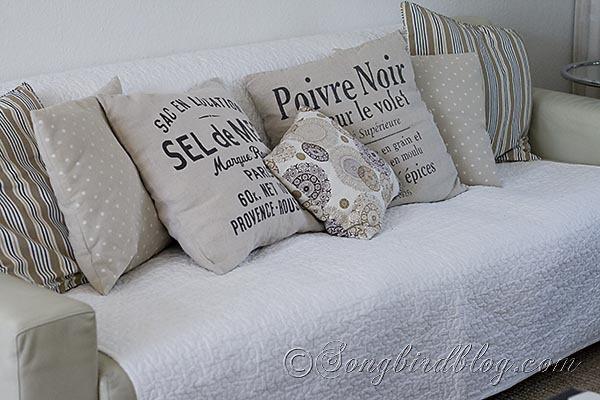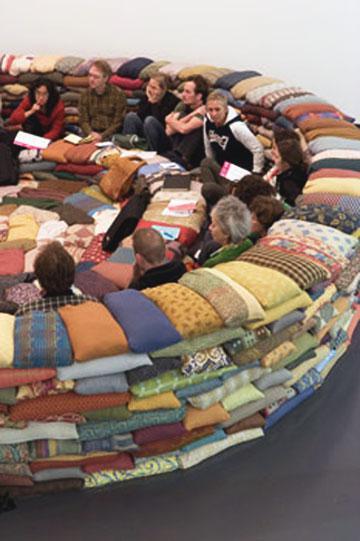The first image is the image on the left, the second image is the image on the right. For the images displayed, is the sentence "In one image, pillows are stacked five across to form a couch-like seating area." factually correct? Answer yes or no. No. 